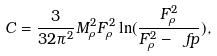<formula> <loc_0><loc_0><loc_500><loc_500>C = \frac { 3 } { 3 2 \pi ^ { 2 } } M ^ { 2 } _ { \rho } F ^ { 2 } _ { \rho } \ln ( \frac { F ^ { 2 } _ { \rho } } { F ^ { 2 } _ { \rho } - \ f p } ) ,</formula> 